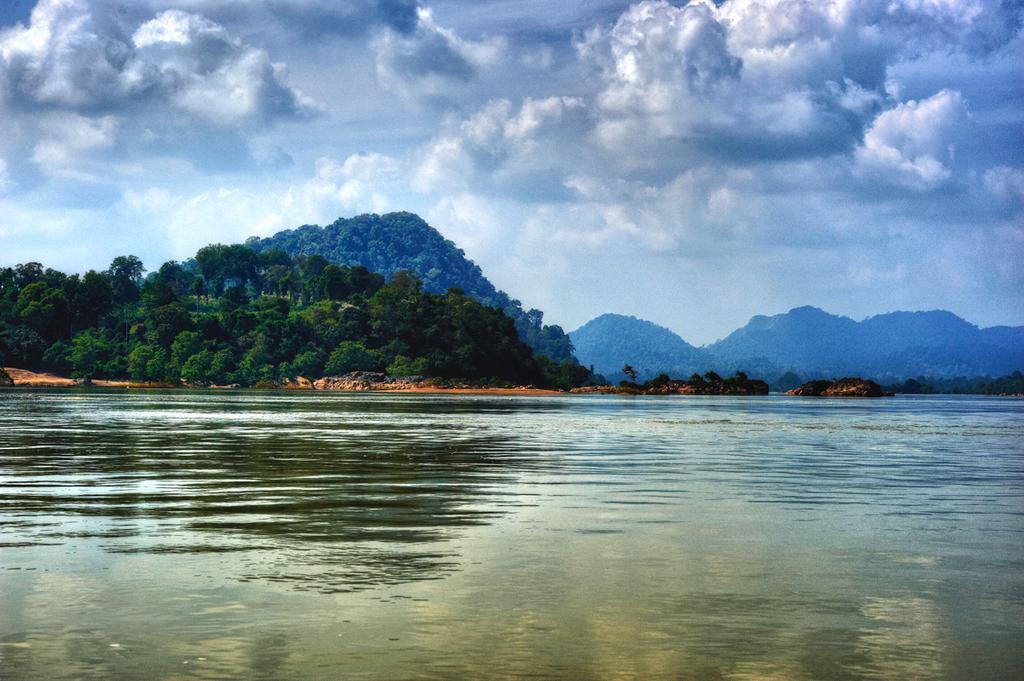In one or two sentences, can you explain what this image depicts? In this image we can see water, trees, mountains and the sky with clouds in the background. 